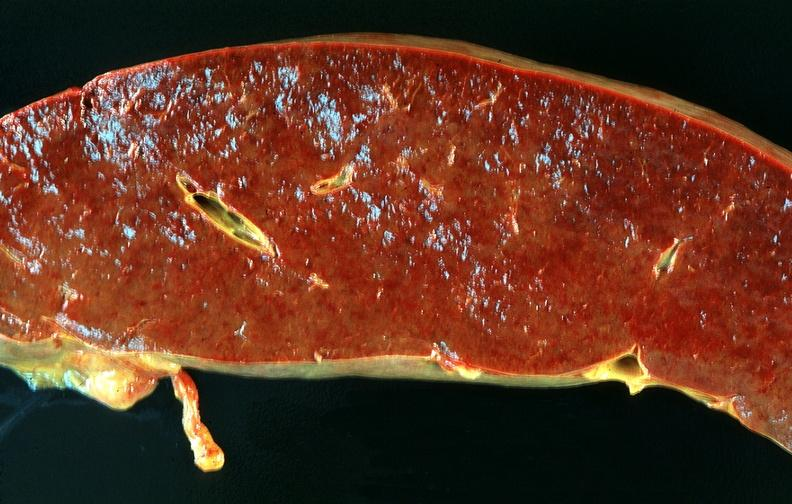does this image show spleen, chronic congestion due to portal hypertension from cirrhosis, hcv?
Answer the question using a single word or phrase. Yes 